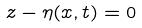Convert formula to latex. <formula><loc_0><loc_0><loc_500><loc_500>z - \eta ( x , t ) = 0</formula> 